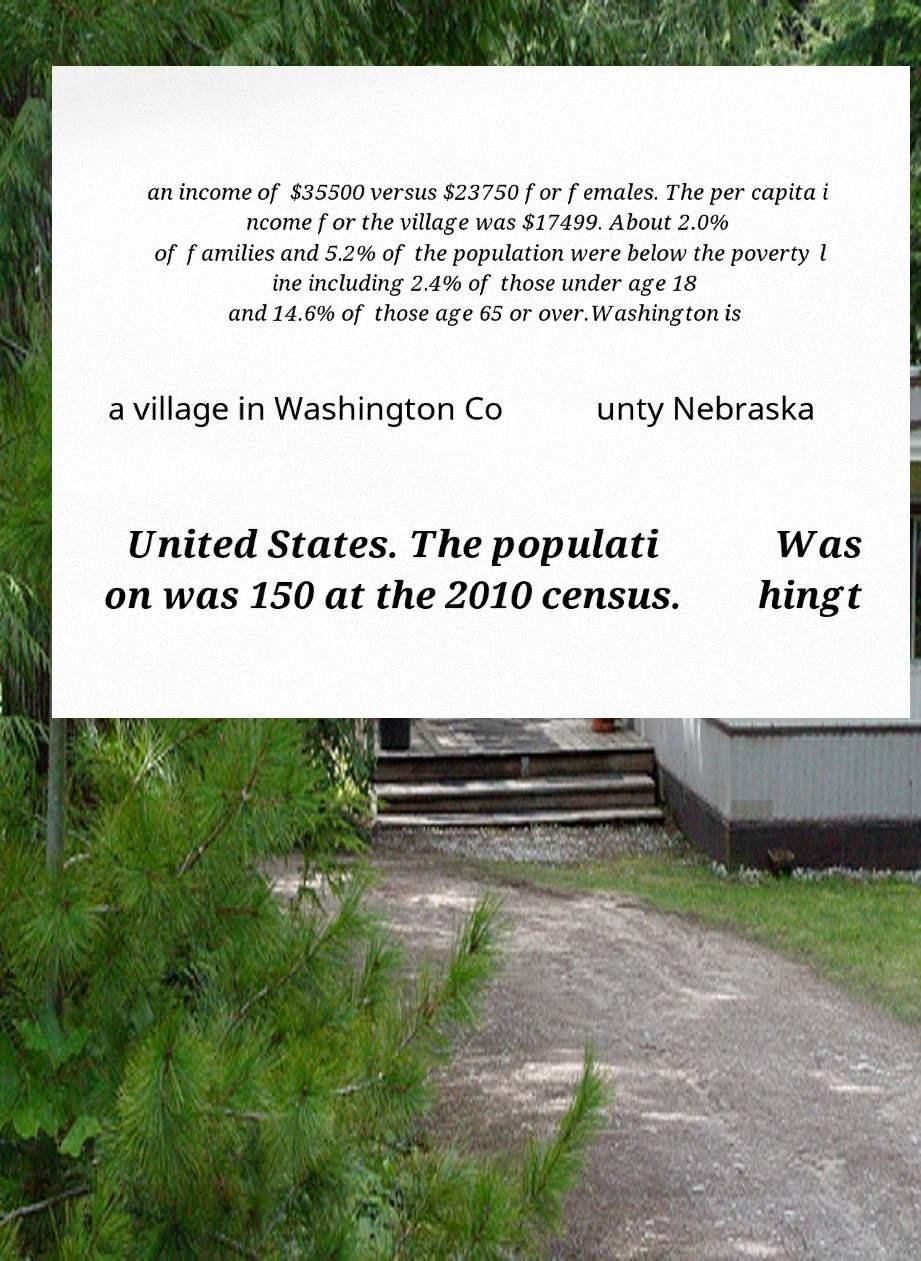There's text embedded in this image that I need extracted. Can you transcribe it verbatim? an income of $35500 versus $23750 for females. The per capita i ncome for the village was $17499. About 2.0% of families and 5.2% of the population were below the poverty l ine including 2.4% of those under age 18 and 14.6% of those age 65 or over.Washington is a village in Washington Co unty Nebraska United States. The populati on was 150 at the 2010 census. Was hingt 